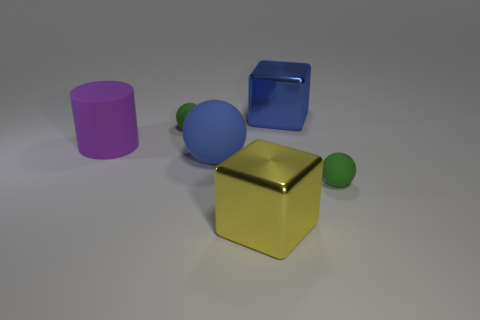Add 3 big rubber objects. How many objects exist? 9 Subtract all cylinders. How many objects are left? 5 Subtract 0 brown cubes. How many objects are left? 6 Subtract all small things. Subtract all spheres. How many objects are left? 1 Add 3 blocks. How many blocks are left? 5 Add 4 green things. How many green things exist? 6 